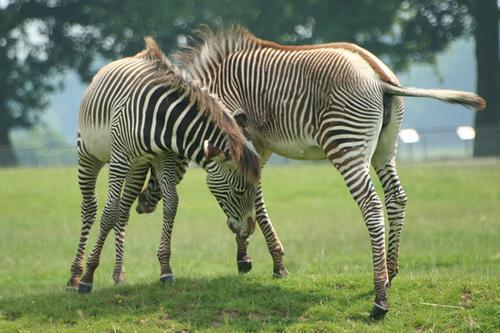How many hooves are on the zebra?
Give a very brief answer. 4. How many zebras are there?
Give a very brief answer. 2. 